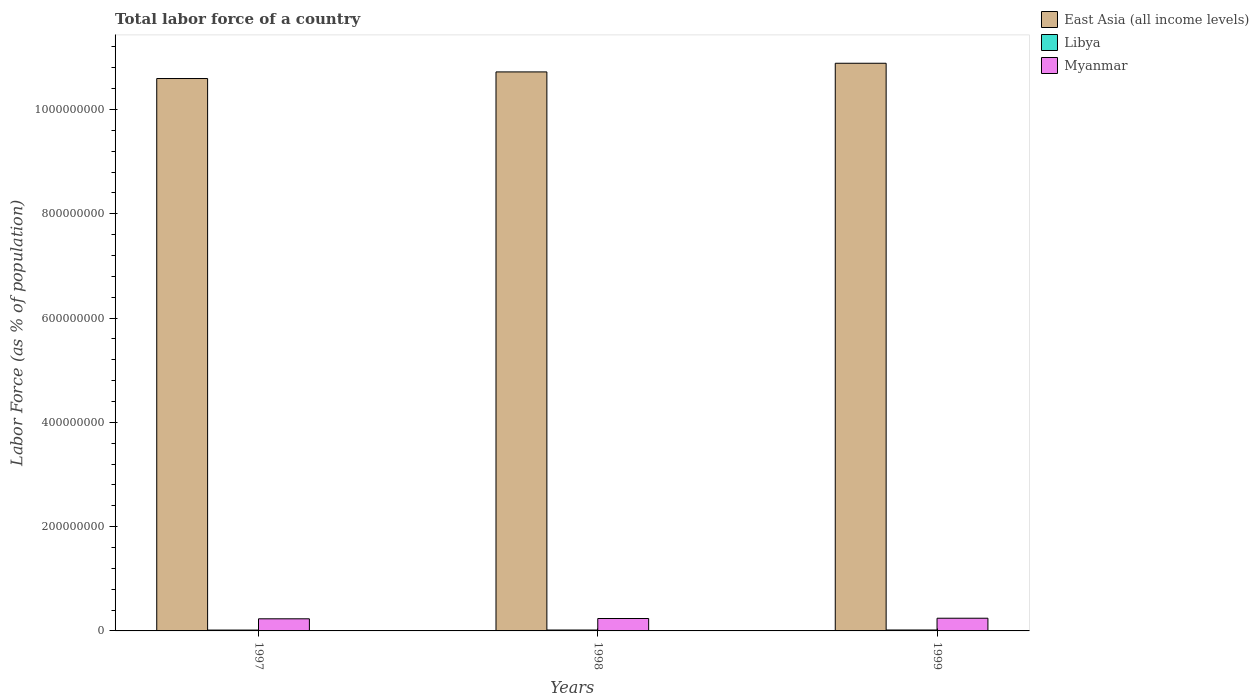Are the number of bars per tick equal to the number of legend labels?
Give a very brief answer. Yes. Are the number of bars on each tick of the X-axis equal?
Provide a succinct answer. Yes. How many bars are there on the 2nd tick from the left?
Provide a short and direct response. 3. How many bars are there on the 3rd tick from the right?
Your answer should be compact. 3. In how many cases, is the number of bars for a given year not equal to the number of legend labels?
Your response must be concise. 0. What is the percentage of labor force in Libya in 1997?
Make the answer very short. 1.65e+06. Across all years, what is the maximum percentage of labor force in Libya?
Offer a very short reply. 1.78e+06. Across all years, what is the minimum percentage of labor force in East Asia (all income levels)?
Offer a very short reply. 1.06e+09. In which year was the percentage of labor force in Myanmar maximum?
Your answer should be very brief. 1999. What is the total percentage of labor force in East Asia (all income levels) in the graph?
Offer a very short reply. 3.22e+09. What is the difference between the percentage of labor force in East Asia (all income levels) in 1997 and that in 1998?
Make the answer very short. -1.27e+07. What is the difference between the percentage of labor force in Libya in 1997 and the percentage of labor force in Myanmar in 1998?
Offer a very short reply. -2.22e+07. What is the average percentage of labor force in Libya per year?
Keep it short and to the point. 1.71e+06. In the year 1998, what is the difference between the percentage of labor force in Myanmar and percentage of labor force in East Asia (all income levels)?
Provide a short and direct response. -1.05e+09. What is the ratio of the percentage of labor force in Libya in 1997 to that in 1999?
Provide a succinct answer. 0.93. Is the difference between the percentage of labor force in Myanmar in 1997 and 1999 greater than the difference between the percentage of labor force in East Asia (all income levels) in 1997 and 1999?
Offer a terse response. Yes. What is the difference between the highest and the second highest percentage of labor force in East Asia (all income levels)?
Ensure brevity in your answer.  1.66e+07. What is the difference between the highest and the lowest percentage of labor force in Libya?
Give a very brief answer. 1.32e+05. Is the sum of the percentage of labor force in Myanmar in 1997 and 1998 greater than the maximum percentage of labor force in Libya across all years?
Offer a very short reply. Yes. What does the 2nd bar from the left in 1997 represents?
Keep it short and to the point. Libya. What does the 2nd bar from the right in 1998 represents?
Offer a very short reply. Libya. How many bars are there?
Give a very brief answer. 9. What is the difference between two consecutive major ticks on the Y-axis?
Keep it short and to the point. 2.00e+08. Does the graph contain grids?
Your answer should be very brief. No. Where does the legend appear in the graph?
Provide a short and direct response. Top right. How many legend labels are there?
Ensure brevity in your answer.  3. What is the title of the graph?
Keep it short and to the point. Total labor force of a country. What is the label or title of the Y-axis?
Provide a succinct answer. Labor Force (as % of population). What is the Labor Force (as % of population) in East Asia (all income levels) in 1997?
Provide a short and direct response. 1.06e+09. What is the Labor Force (as % of population) in Libya in 1997?
Offer a terse response. 1.65e+06. What is the Labor Force (as % of population) of Myanmar in 1997?
Provide a short and direct response. 2.32e+07. What is the Labor Force (as % of population) in East Asia (all income levels) in 1998?
Give a very brief answer. 1.07e+09. What is the Labor Force (as % of population) of Libya in 1998?
Your answer should be compact. 1.71e+06. What is the Labor Force (as % of population) of Myanmar in 1998?
Offer a very short reply. 2.38e+07. What is the Labor Force (as % of population) in East Asia (all income levels) in 1999?
Provide a succinct answer. 1.09e+09. What is the Labor Force (as % of population) in Libya in 1999?
Make the answer very short. 1.78e+06. What is the Labor Force (as % of population) of Myanmar in 1999?
Keep it short and to the point. 2.44e+07. Across all years, what is the maximum Labor Force (as % of population) of East Asia (all income levels)?
Offer a terse response. 1.09e+09. Across all years, what is the maximum Labor Force (as % of population) in Libya?
Ensure brevity in your answer.  1.78e+06. Across all years, what is the maximum Labor Force (as % of population) in Myanmar?
Your answer should be compact. 2.44e+07. Across all years, what is the minimum Labor Force (as % of population) in East Asia (all income levels)?
Give a very brief answer. 1.06e+09. Across all years, what is the minimum Labor Force (as % of population) in Libya?
Offer a terse response. 1.65e+06. Across all years, what is the minimum Labor Force (as % of population) of Myanmar?
Offer a terse response. 2.32e+07. What is the total Labor Force (as % of population) in East Asia (all income levels) in the graph?
Offer a very short reply. 3.22e+09. What is the total Labor Force (as % of population) in Libya in the graph?
Give a very brief answer. 5.14e+06. What is the total Labor Force (as % of population) of Myanmar in the graph?
Keep it short and to the point. 7.14e+07. What is the difference between the Labor Force (as % of population) in East Asia (all income levels) in 1997 and that in 1998?
Give a very brief answer. -1.27e+07. What is the difference between the Labor Force (as % of population) in Libya in 1997 and that in 1998?
Provide a succinct answer. -6.68e+04. What is the difference between the Labor Force (as % of population) in Myanmar in 1997 and that in 1998?
Your answer should be compact. -5.60e+05. What is the difference between the Labor Force (as % of population) of East Asia (all income levels) in 1997 and that in 1999?
Offer a very short reply. -2.93e+07. What is the difference between the Labor Force (as % of population) in Libya in 1997 and that in 1999?
Provide a short and direct response. -1.32e+05. What is the difference between the Labor Force (as % of population) of Myanmar in 1997 and that in 1999?
Your answer should be compact. -1.10e+06. What is the difference between the Labor Force (as % of population) of East Asia (all income levels) in 1998 and that in 1999?
Make the answer very short. -1.66e+07. What is the difference between the Labor Force (as % of population) in Libya in 1998 and that in 1999?
Give a very brief answer. -6.55e+04. What is the difference between the Labor Force (as % of population) in Myanmar in 1998 and that in 1999?
Your answer should be very brief. -5.44e+05. What is the difference between the Labor Force (as % of population) of East Asia (all income levels) in 1997 and the Labor Force (as % of population) of Libya in 1998?
Your response must be concise. 1.06e+09. What is the difference between the Labor Force (as % of population) in East Asia (all income levels) in 1997 and the Labor Force (as % of population) in Myanmar in 1998?
Give a very brief answer. 1.04e+09. What is the difference between the Labor Force (as % of population) of Libya in 1997 and the Labor Force (as % of population) of Myanmar in 1998?
Offer a terse response. -2.22e+07. What is the difference between the Labor Force (as % of population) in East Asia (all income levels) in 1997 and the Labor Force (as % of population) in Libya in 1999?
Offer a very short reply. 1.06e+09. What is the difference between the Labor Force (as % of population) in East Asia (all income levels) in 1997 and the Labor Force (as % of population) in Myanmar in 1999?
Keep it short and to the point. 1.03e+09. What is the difference between the Labor Force (as % of population) of Libya in 1997 and the Labor Force (as % of population) of Myanmar in 1999?
Your answer should be very brief. -2.27e+07. What is the difference between the Labor Force (as % of population) in East Asia (all income levels) in 1998 and the Labor Force (as % of population) in Libya in 1999?
Provide a short and direct response. 1.07e+09. What is the difference between the Labor Force (as % of population) in East Asia (all income levels) in 1998 and the Labor Force (as % of population) in Myanmar in 1999?
Make the answer very short. 1.05e+09. What is the difference between the Labor Force (as % of population) of Libya in 1998 and the Labor Force (as % of population) of Myanmar in 1999?
Provide a succinct answer. -2.26e+07. What is the average Labor Force (as % of population) in East Asia (all income levels) per year?
Your answer should be very brief. 1.07e+09. What is the average Labor Force (as % of population) of Libya per year?
Your response must be concise. 1.71e+06. What is the average Labor Force (as % of population) in Myanmar per year?
Give a very brief answer. 2.38e+07. In the year 1997, what is the difference between the Labor Force (as % of population) of East Asia (all income levels) and Labor Force (as % of population) of Libya?
Your answer should be compact. 1.06e+09. In the year 1997, what is the difference between the Labor Force (as % of population) in East Asia (all income levels) and Labor Force (as % of population) in Myanmar?
Your answer should be very brief. 1.04e+09. In the year 1997, what is the difference between the Labor Force (as % of population) of Libya and Labor Force (as % of population) of Myanmar?
Offer a very short reply. -2.16e+07. In the year 1998, what is the difference between the Labor Force (as % of population) of East Asia (all income levels) and Labor Force (as % of population) of Libya?
Offer a terse response. 1.07e+09. In the year 1998, what is the difference between the Labor Force (as % of population) of East Asia (all income levels) and Labor Force (as % of population) of Myanmar?
Give a very brief answer. 1.05e+09. In the year 1998, what is the difference between the Labor Force (as % of population) of Libya and Labor Force (as % of population) of Myanmar?
Give a very brief answer. -2.21e+07. In the year 1999, what is the difference between the Labor Force (as % of population) in East Asia (all income levels) and Labor Force (as % of population) in Libya?
Your answer should be very brief. 1.09e+09. In the year 1999, what is the difference between the Labor Force (as % of population) of East Asia (all income levels) and Labor Force (as % of population) of Myanmar?
Offer a terse response. 1.06e+09. In the year 1999, what is the difference between the Labor Force (as % of population) of Libya and Labor Force (as % of population) of Myanmar?
Keep it short and to the point. -2.26e+07. What is the ratio of the Labor Force (as % of population) in Myanmar in 1997 to that in 1998?
Provide a short and direct response. 0.98. What is the ratio of the Labor Force (as % of population) in East Asia (all income levels) in 1997 to that in 1999?
Your answer should be very brief. 0.97. What is the ratio of the Labor Force (as % of population) of Libya in 1997 to that in 1999?
Your response must be concise. 0.93. What is the ratio of the Labor Force (as % of population) in Myanmar in 1997 to that in 1999?
Ensure brevity in your answer.  0.95. What is the ratio of the Labor Force (as % of population) of Libya in 1998 to that in 1999?
Your response must be concise. 0.96. What is the ratio of the Labor Force (as % of population) in Myanmar in 1998 to that in 1999?
Provide a succinct answer. 0.98. What is the difference between the highest and the second highest Labor Force (as % of population) of East Asia (all income levels)?
Give a very brief answer. 1.66e+07. What is the difference between the highest and the second highest Labor Force (as % of population) of Libya?
Your response must be concise. 6.55e+04. What is the difference between the highest and the second highest Labor Force (as % of population) in Myanmar?
Keep it short and to the point. 5.44e+05. What is the difference between the highest and the lowest Labor Force (as % of population) in East Asia (all income levels)?
Provide a short and direct response. 2.93e+07. What is the difference between the highest and the lowest Labor Force (as % of population) of Libya?
Ensure brevity in your answer.  1.32e+05. What is the difference between the highest and the lowest Labor Force (as % of population) in Myanmar?
Offer a terse response. 1.10e+06. 